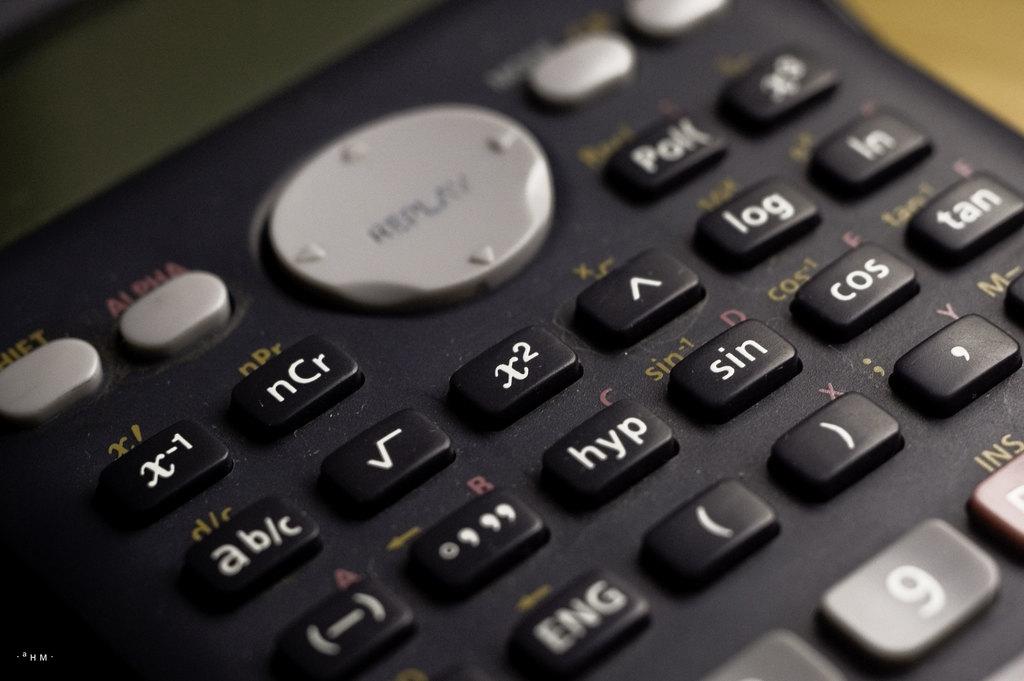What does the big grey circle do?
Ensure brevity in your answer.  Replay. What number key is shown?
Your answer should be very brief. 9. 